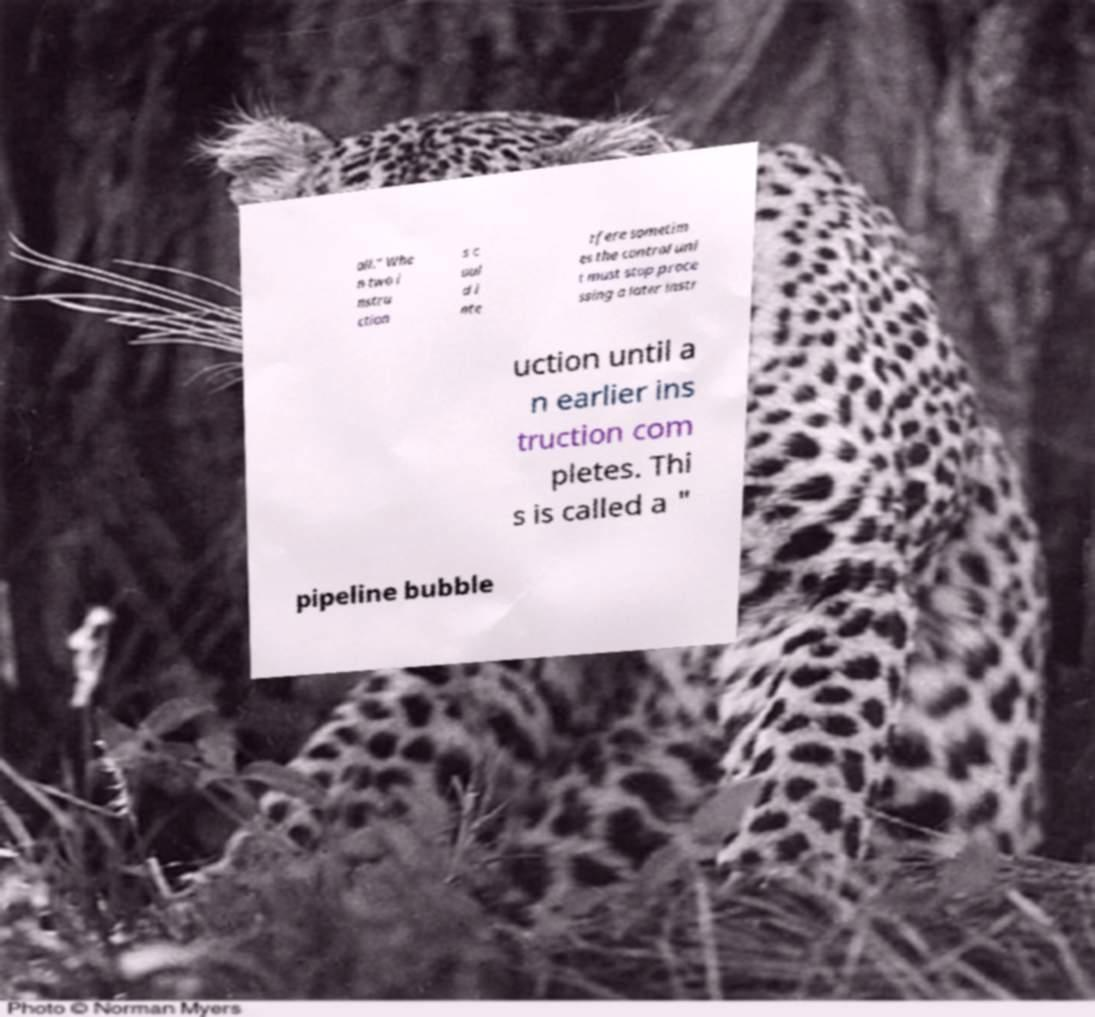There's text embedded in this image that I need extracted. Can you transcribe it verbatim? all." Whe n two i nstru ction s c oul d i nte rfere sometim es the control uni t must stop proce ssing a later instr uction until a n earlier ins truction com pletes. Thi s is called a " pipeline bubble 